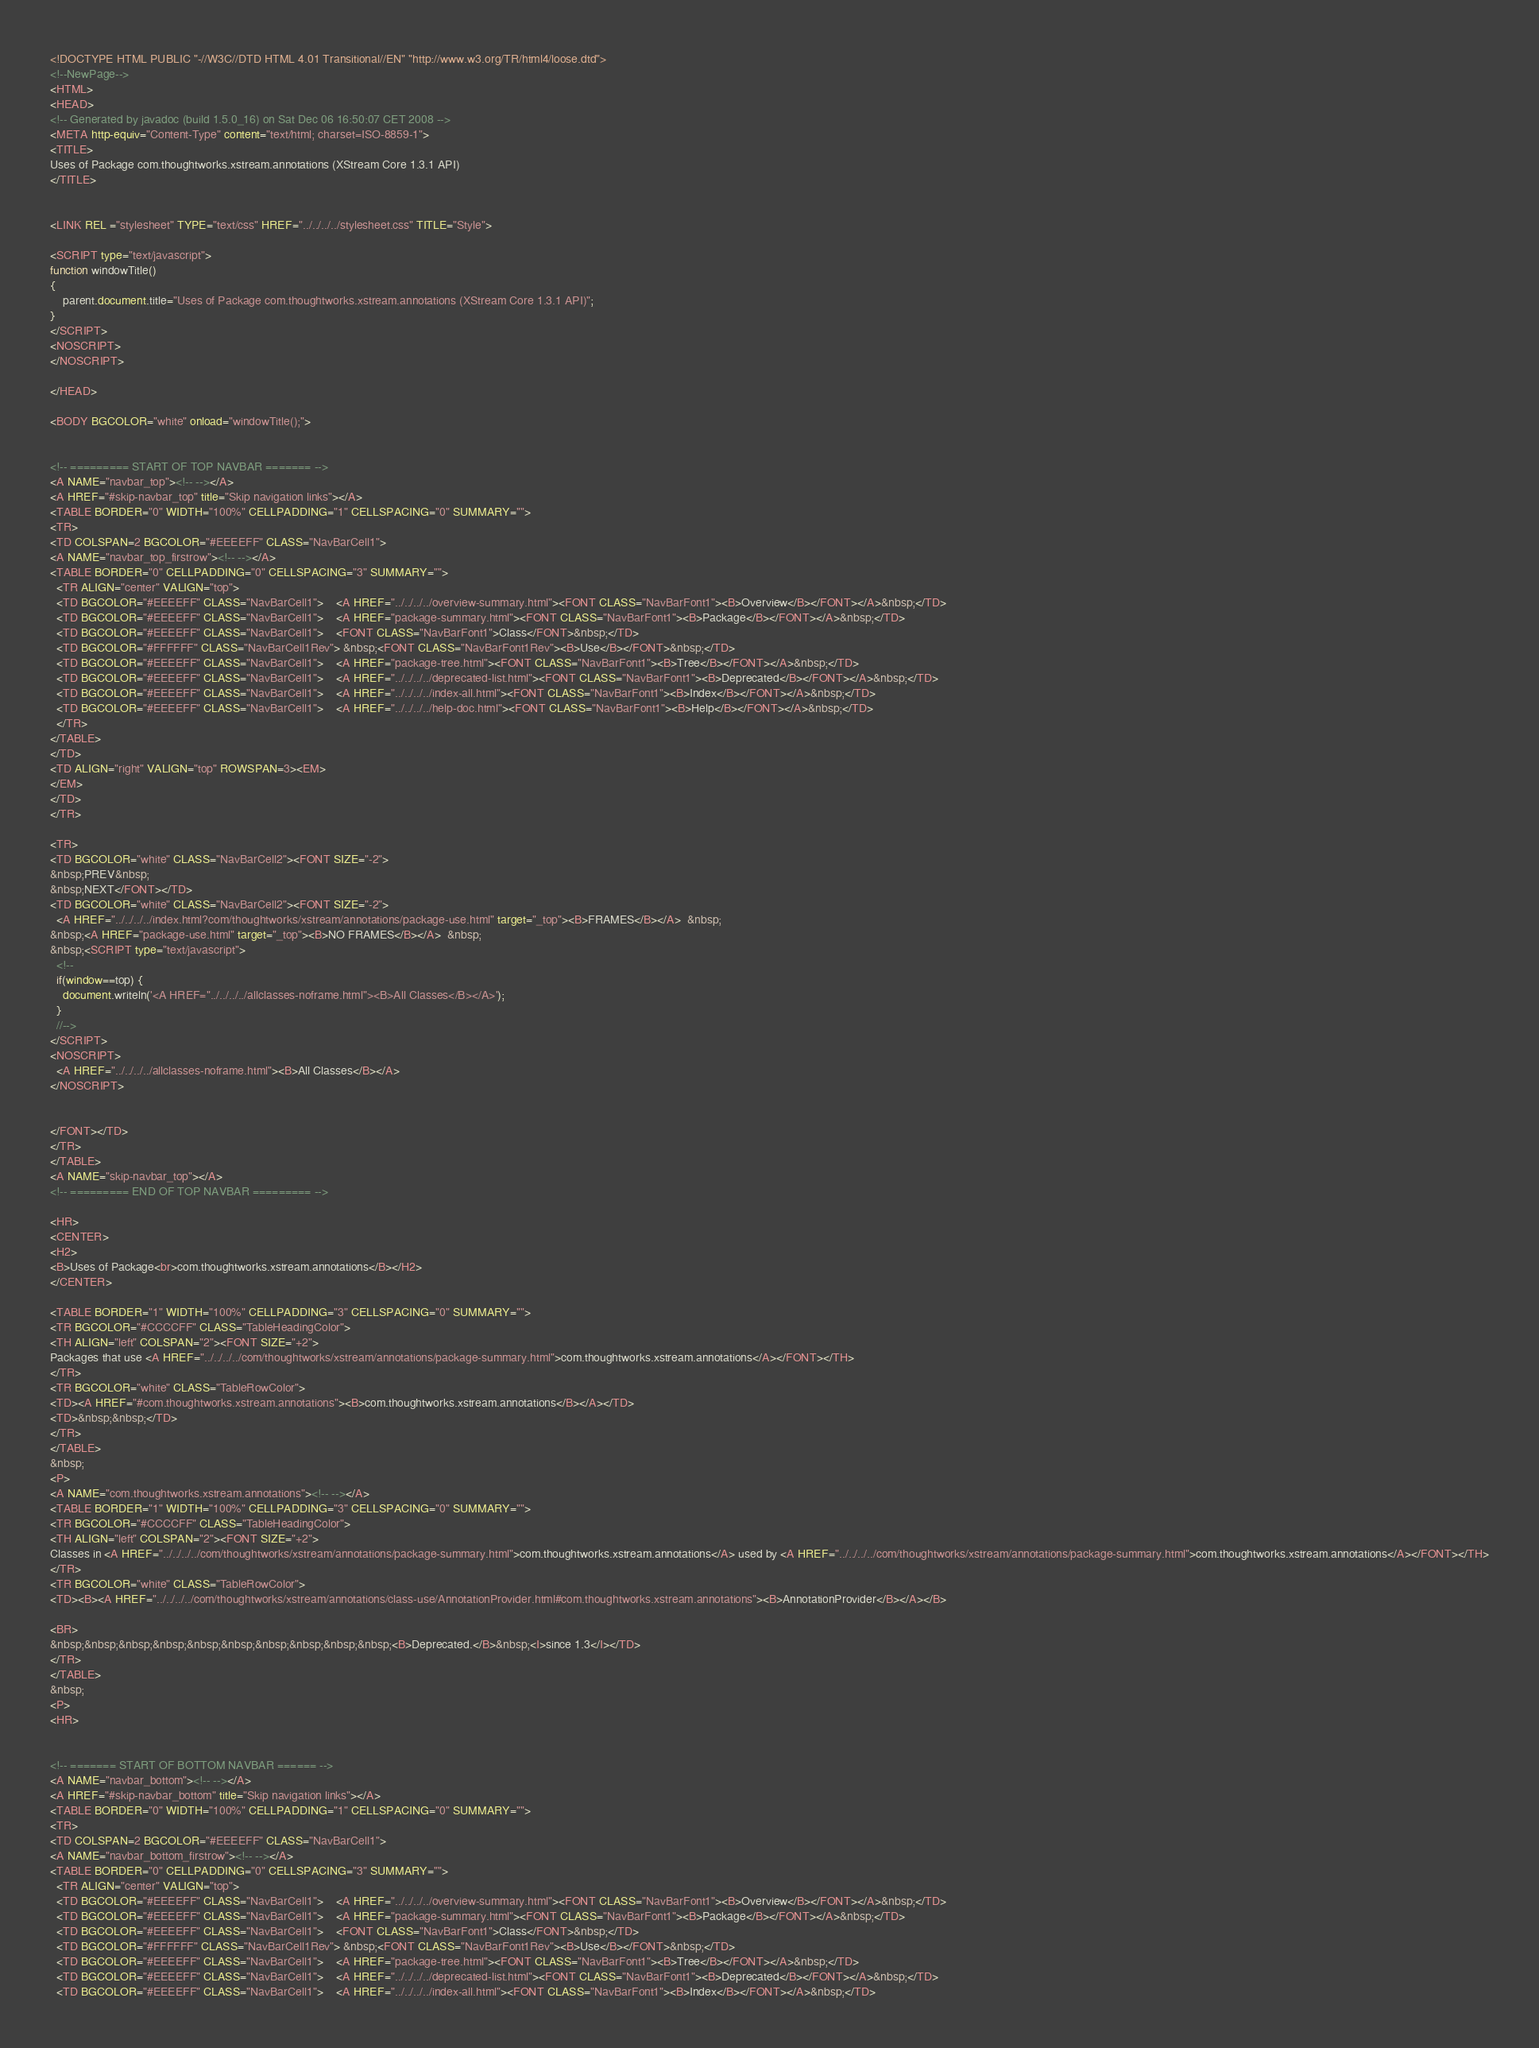<code> <loc_0><loc_0><loc_500><loc_500><_HTML_><!DOCTYPE HTML PUBLIC "-//W3C//DTD HTML 4.01 Transitional//EN" "http://www.w3.org/TR/html4/loose.dtd">
<!--NewPage-->
<HTML>
<HEAD>
<!-- Generated by javadoc (build 1.5.0_16) on Sat Dec 06 16:50:07 CET 2008 -->
<META http-equiv="Content-Type" content="text/html; charset=ISO-8859-1">
<TITLE>
Uses of Package com.thoughtworks.xstream.annotations (XStream Core 1.3.1 API)
</TITLE>


<LINK REL ="stylesheet" TYPE="text/css" HREF="../../../../stylesheet.css" TITLE="Style">

<SCRIPT type="text/javascript">
function windowTitle()
{
    parent.document.title="Uses of Package com.thoughtworks.xstream.annotations (XStream Core 1.3.1 API)";
}
</SCRIPT>
<NOSCRIPT>
</NOSCRIPT>

</HEAD>

<BODY BGCOLOR="white" onload="windowTitle();">


<!-- ========= START OF TOP NAVBAR ======= -->
<A NAME="navbar_top"><!-- --></A>
<A HREF="#skip-navbar_top" title="Skip navigation links"></A>
<TABLE BORDER="0" WIDTH="100%" CELLPADDING="1" CELLSPACING="0" SUMMARY="">
<TR>
<TD COLSPAN=2 BGCOLOR="#EEEEFF" CLASS="NavBarCell1">
<A NAME="navbar_top_firstrow"><!-- --></A>
<TABLE BORDER="0" CELLPADDING="0" CELLSPACING="3" SUMMARY="">
  <TR ALIGN="center" VALIGN="top">
  <TD BGCOLOR="#EEEEFF" CLASS="NavBarCell1">    <A HREF="../../../../overview-summary.html"><FONT CLASS="NavBarFont1"><B>Overview</B></FONT></A>&nbsp;</TD>
  <TD BGCOLOR="#EEEEFF" CLASS="NavBarCell1">    <A HREF="package-summary.html"><FONT CLASS="NavBarFont1"><B>Package</B></FONT></A>&nbsp;</TD>
  <TD BGCOLOR="#EEEEFF" CLASS="NavBarCell1">    <FONT CLASS="NavBarFont1">Class</FONT>&nbsp;</TD>
  <TD BGCOLOR="#FFFFFF" CLASS="NavBarCell1Rev"> &nbsp;<FONT CLASS="NavBarFont1Rev"><B>Use</B></FONT>&nbsp;</TD>
  <TD BGCOLOR="#EEEEFF" CLASS="NavBarCell1">    <A HREF="package-tree.html"><FONT CLASS="NavBarFont1"><B>Tree</B></FONT></A>&nbsp;</TD>
  <TD BGCOLOR="#EEEEFF" CLASS="NavBarCell1">    <A HREF="../../../../deprecated-list.html"><FONT CLASS="NavBarFont1"><B>Deprecated</B></FONT></A>&nbsp;</TD>
  <TD BGCOLOR="#EEEEFF" CLASS="NavBarCell1">    <A HREF="../../../../index-all.html"><FONT CLASS="NavBarFont1"><B>Index</B></FONT></A>&nbsp;</TD>
  <TD BGCOLOR="#EEEEFF" CLASS="NavBarCell1">    <A HREF="../../../../help-doc.html"><FONT CLASS="NavBarFont1"><B>Help</B></FONT></A>&nbsp;</TD>
  </TR>
</TABLE>
</TD>
<TD ALIGN="right" VALIGN="top" ROWSPAN=3><EM>
</EM>
</TD>
</TR>

<TR>
<TD BGCOLOR="white" CLASS="NavBarCell2"><FONT SIZE="-2">
&nbsp;PREV&nbsp;
&nbsp;NEXT</FONT></TD>
<TD BGCOLOR="white" CLASS="NavBarCell2"><FONT SIZE="-2">
  <A HREF="../../../../index.html?com/thoughtworks/xstream/annotations/package-use.html" target="_top"><B>FRAMES</B></A>  &nbsp;
&nbsp;<A HREF="package-use.html" target="_top"><B>NO FRAMES</B></A>  &nbsp;
&nbsp;<SCRIPT type="text/javascript">
  <!--
  if(window==top) {
    document.writeln('<A HREF="../../../../allclasses-noframe.html"><B>All Classes</B></A>');
  }
  //-->
</SCRIPT>
<NOSCRIPT>
  <A HREF="../../../../allclasses-noframe.html"><B>All Classes</B></A>
</NOSCRIPT>


</FONT></TD>
</TR>
</TABLE>
<A NAME="skip-navbar_top"></A>
<!-- ========= END OF TOP NAVBAR ========= -->

<HR>
<CENTER>
<H2>
<B>Uses of Package<br>com.thoughtworks.xstream.annotations</B></H2>
</CENTER>

<TABLE BORDER="1" WIDTH="100%" CELLPADDING="3" CELLSPACING="0" SUMMARY="">
<TR BGCOLOR="#CCCCFF" CLASS="TableHeadingColor">
<TH ALIGN="left" COLSPAN="2"><FONT SIZE="+2">
Packages that use <A HREF="../../../../com/thoughtworks/xstream/annotations/package-summary.html">com.thoughtworks.xstream.annotations</A></FONT></TH>
</TR>
<TR BGCOLOR="white" CLASS="TableRowColor">
<TD><A HREF="#com.thoughtworks.xstream.annotations"><B>com.thoughtworks.xstream.annotations</B></A></TD>
<TD>&nbsp;&nbsp;</TD>
</TR>
</TABLE>
&nbsp;
<P>
<A NAME="com.thoughtworks.xstream.annotations"><!-- --></A>
<TABLE BORDER="1" WIDTH="100%" CELLPADDING="3" CELLSPACING="0" SUMMARY="">
<TR BGCOLOR="#CCCCFF" CLASS="TableHeadingColor">
<TH ALIGN="left" COLSPAN="2"><FONT SIZE="+2">
Classes in <A HREF="../../../../com/thoughtworks/xstream/annotations/package-summary.html">com.thoughtworks.xstream.annotations</A> used by <A HREF="../../../../com/thoughtworks/xstream/annotations/package-summary.html">com.thoughtworks.xstream.annotations</A></FONT></TH>
</TR>
<TR BGCOLOR="white" CLASS="TableRowColor">
<TD><B><A HREF="../../../../com/thoughtworks/xstream/annotations/class-use/AnnotationProvider.html#com.thoughtworks.xstream.annotations"><B>AnnotationProvider</B></A></B>

<BR>
&nbsp;&nbsp;&nbsp;&nbsp;&nbsp;&nbsp;&nbsp;&nbsp;&nbsp;&nbsp;<B>Deprecated.</B>&nbsp;<I>since 1.3</I></TD>
</TR>
</TABLE>
&nbsp;
<P>
<HR>


<!-- ======= START OF BOTTOM NAVBAR ====== -->
<A NAME="navbar_bottom"><!-- --></A>
<A HREF="#skip-navbar_bottom" title="Skip navigation links"></A>
<TABLE BORDER="0" WIDTH="100%" CELLPADDING="1" CELLSPACING="0" SUMMARY="">
<TR>
<TD COLSPAN=2 BGCOLOR="#EEEEFF" CLASS="NavBarCell1">
<A NAME="navbar_bottom_firstrow"><!-- --></A>
<TABLE BORDER="0" CELLPADDING="0" CELLSPACING="3" SUMMARY="">
  <TR ALIGN="center" VALIGN="top">
  <TD BGCOLOR="#EEEEFF" CLASS="NavBarCell1">    <A HREF="../../../../overview-summary.html"><FONT CLASS="NavBarFont1"><B>Overview</B></FONT></A>&nbsp;</TD>
  <TD BGCOLOR="#EEEEFF" CLASS="NavBarCell1">    <A HREF="package-summary.html"><FONT CLASS="NavBarFont1"><B>Package</B></FONT></A>&nbsp;</TD>
  <TD BGCOLOR="#EEEEFF" CLASS="NavBarCell1">    <FONT CLASS="NavBarFont1">Class</FONT>&nbsp;</TD>
  <TD BGCOLOR="#FFFFFF" CLASS="NavBarCell1Rev"> &nbsp;<FONT CLASS="NavBarFont1Rev"><B>Use</B></FONT>&nbsp;</TD>
  <TD BGCOLOR="#EEEEFF" CLASS="NavBarCell1">    <A HREF="package-tree.html"><FONT CLASS="NavBarFont1"><B>Tree</B></FONT></A>&nbsp;</TD>
  <TD BGCOLOR="#EEEEFF" CLASS="NavBarCell1">    <A HREF="../../../../deprecated-list.html"><FONT CLASS="NavBarFont1"><B>Deprecated</B></FONT></A>&nbsp;</TD>
  <TD BGCOLOR="#EEEEFF" CLASS="NavBarCell1">    <A HREF="../../../../index-all.html"><FONT CLASS="NavBarFont1"><B>Index</B></FONT></A>&nbsp;</TD></code> 